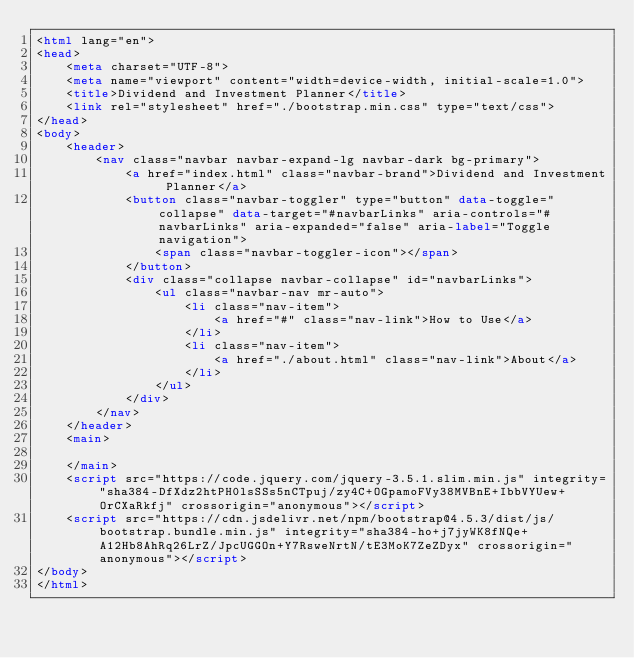<code> <loc_0><loc_0><loc_500><loc_500><_HTML_><html lang="en">
<head>
    <meta charset="UTF-8">
    <meta name="viewport" content="width=device-width, initial-scale=1.0">
    <title>Dividend and Investment Planner</title>
    <link rel="stylesheet" href="./bootstrap.min.css" type="text/css">
</head>
<body>
    <header>
        <nav class="navbar navbar-expand-lg navbar-dark bg-primary">
            <a href="index.html" class="navbar-brand">Dividend and Investment Planner</a>
            <button class="navbar-toggler" type="button" data-toggle="collapse" data-target="#navbarLinks" aria-controls="#navbarLinks" aria-expanded="false" aria-label="Toggle navigation">
                <span class="navbar-toggler-icon"></span>
            </button>
            <div class="collapse navbar-collapse" id="navbarLinks">
                <ul class="navbar-nav mr-auto">
                    <li class="nav-item">
                        <a href="#" class="nav-link">How to Use</a>
                    </li>
                    <li class="nav-item">
                        <a href="./about.html" class="nav-link">About</a>
                    </li>
                </ul>
            </div>
        </nav>
    </header>
    <main>

    </main>
    <script src="https://code.jquery.com/jquery-3.5.1.slim.min.js" integrity="sha384-DfXdz2htPH0lsSSs5nCTpuj/zy4C+OGpamoFVy38MVBnE+IbbVYUew+OrCXaRkfj" crossorigin="anonymous"></script>
    <script src="https://cdn.jsdelivr.net/npm/bootstrap@4.5.3/dist/js/bootstrap.bundle.min.js" integrity="sha384-ho+j7jyWK8fNQe+A12Hb8AhRq26LrZ/JpcUGGOn+Y7RsweNrtN/tE3MoK7ZeZDyx" crossorigin="anonymous"></script>
</body>
</html></code> 